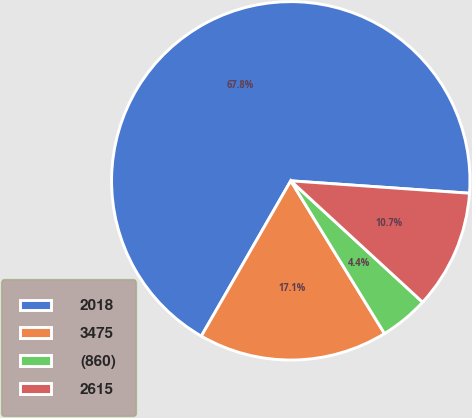Convert chart to OTSL. <chart><loc_0><loc_0><loc_500><loc_500><pie_chart><fcel>2018<fcel>3475<fcel>(860)<fcel>2615<nl><fcel>67.79%<fcel>17.08%<fcel>4.4%<fcel>10.74%<nl></chart> 